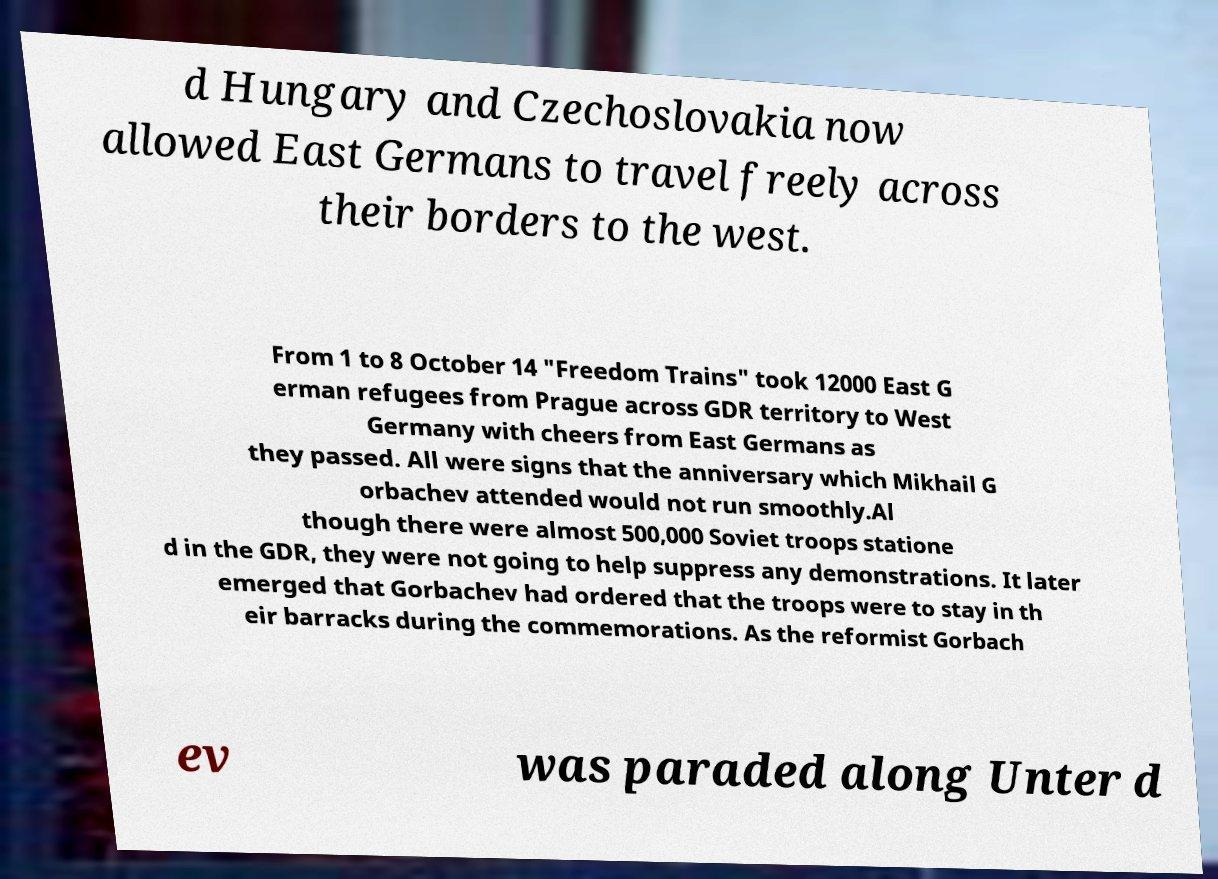Can you accurately transcribe the text from the provided image for me? d Hungary and Czechoslovakia now allowed East Germans to travel freely across their borders to the west. From 1 to 8 October 14 "Freedom Trains" took 12000 East G erman refugees from Prague across GDR territory to West Germany with cheers from East Germans as they passed. All were signs that the anniversary which Mikhail G orbachev attended would not run smoothly.Al though there were almost 500,000 Soviet troops statione d in the GDR, they were not going to help suppress any demonstrations. It later emerged that Gorbachev had ordered that the troops were to stay in th eir barracks during the commemorations. As the reformist Gorbach ev was paraded along Unter d 